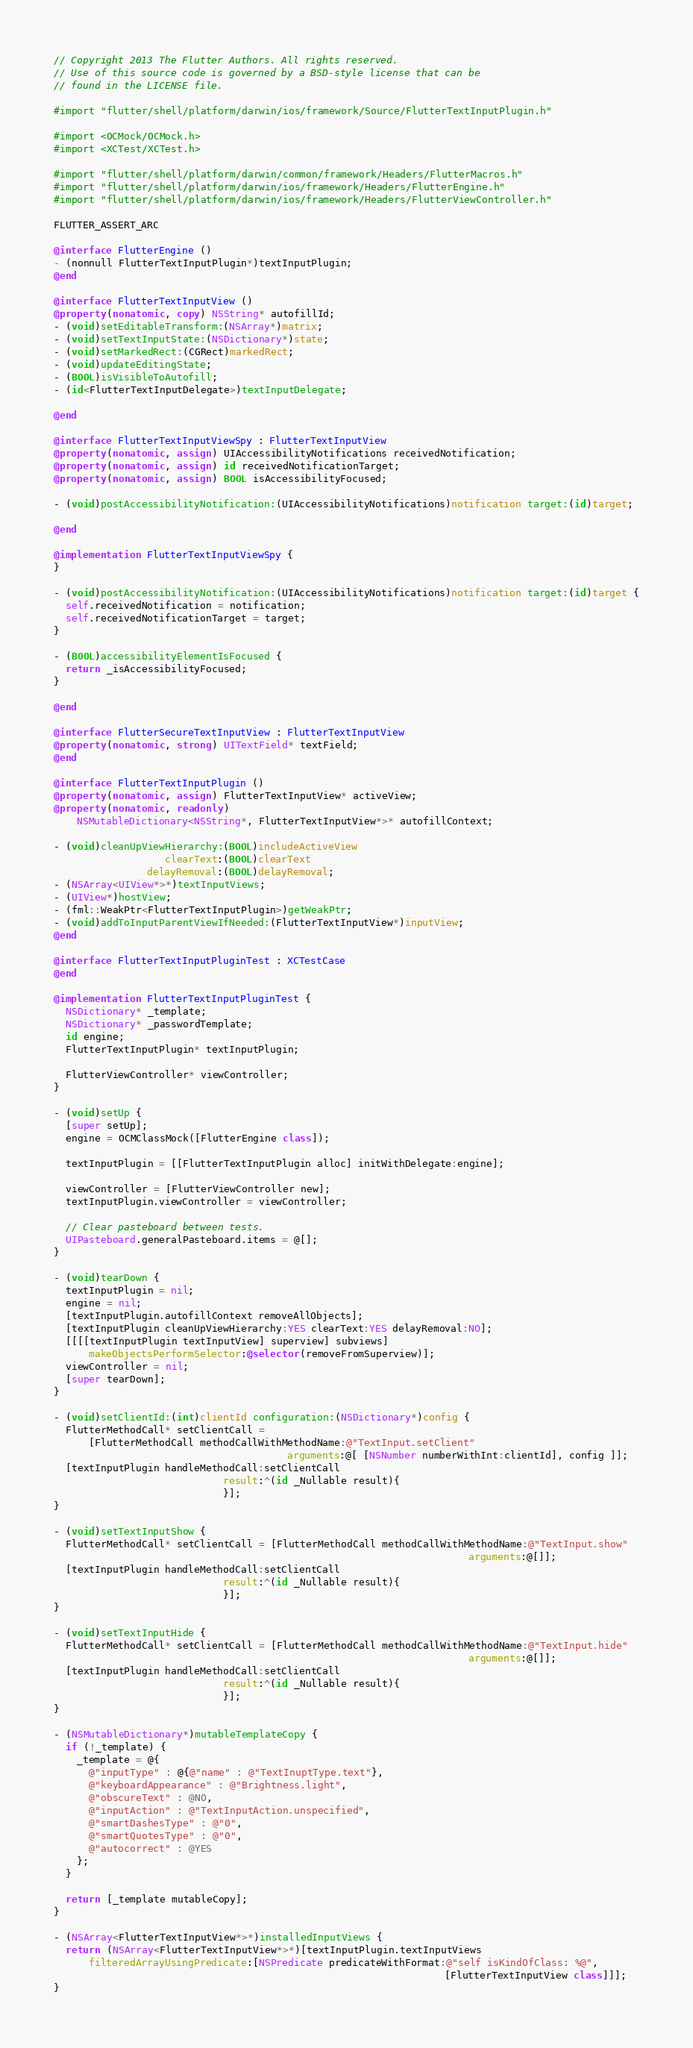<code> <loc_0><loc_0><loc_500><loc_500><_ObjectiveC_>// Copyright 2013 The Flutter Authors. All rights reserved.
// Use of this source code is governed by a BSD-style license that can be
// found in the LICENSE file.

#import "flutter/shell/platform/darwin/ios/framework/Source/FlutterTextInputPlugin.h"

#import <OCMock/OCMock.h>
#import <XCTest/XCTest.h>

#import "flutter/shell/platform/darwin/common/framework/Headers/FlutterMacros.h"
#import "flutter/shell/platform/darwin/ios/framework/Headers/FlutterEngine.h"
#import "flutter/shell/platform/darwin/ios/framework/Headers/FlutterViewController.h"

FLUTTER_ASSERT_ARC

@interface FlutterEngine ()
- (nonnull FlutterTextInputPlugin*)textInputPlugin;
@end

@interface FlutterTextInputView ()
@property(nonatomic, copy) NSString* autofillId;
- (void)setEditableTransform:(NSArray*)matrix;
- (void)setTextInputState:(NSDictionary*)state;
- (void)setMarkedRect:(CGRect)markedRect;
- (void)updateEditingState;
- (BOOL)isVisibleToAutofill;
- (id<FlutterTextInputDelegate>)textInputDelegate;

@end

@interface FlutterTextInputViewSpy : FlutterTextInputView
@property(nonatomic, assign) UIAccessibilityNotifications receivedNotification;
@property(nonatomic, assign) id receivedNotificationTarget;
@property(nonatomic, assign) BOOL isAccessibilityFocused;

- (void)postAccessibilityNotification:(UIAccessibilityNotifications)notification target:(id)target;

@end

@implementation FlutterTextInputViewSpy {
}

- (void)postAccessibilityNotification:(UIAccessibilityNotifications)notification target:(id)target {
  self.receivedNotification = notification;
  self.receivedNotificationTarget = target;
}

- (BOOL)accessibilityElementIsFocused {
  return _isAccessibilityFocused;
}

@end

@interface FlutterSecureTextInputView : FlutterTextInputView
@property(nonatomic, strong) UITextField* textField;
@end

@interface FlutterTextInputPlugin ()
@property(nonatomic, assign) FlutterTextInputView* activeView;
@property(nonatomic, readonly)
    NSMutableDictionary<NSString*, FlutterTextInputView*>* autofillContext;

- (void)cleanUpViewHierarchy:(BOOL)includeActiveView
                   clearText:(BOOL)clearText
                delayRemoval:(BOOL)delayRemoval;
- (NSArray<UIView*>*)textInputViews;
- (UIView*)hostView;
- (fml::WeakPtr<FlutterTextInputPlugin>)getWeakPtr;
- (void)addToInputParentViewIfNeeded:(FlutterTextInputView*)inputView;
@end

@interface FlutterTextInputPluginTest : XCTestCase
@end

@implementation FlutterTextInputPluginTest {
  NSDictionary* _template;
  NSDictionary* _passwordTemplate;
  id engine;
  FlutterTextInputPlugin* textInputPlugin;

  FlutterViewController* viewController;
}

- (void)setUp {
  [super setUp];
  engine = OCMClassMock([FlutterEngine class]);

  textInputPlugin = [[FlutterTextInputPlugin alloc] initWithDelegate:engine];

  viewController = [FlutterViewController new];
  textInputPlugin.viewController = viewController;

  // Clear pasteboard between tests.
  UIPasteboard.generalPasteboard.items = @[];
}

- (void)tearDown {
  textInputPlugin = nil;
  engine = nil;
  [textInputPlugin.autofillContext removeAllObjects];
  [textInputPlugin cleanUpViewHierarchy:YES clearText:YES delayRemoval:NO];
  [[[[textInputPlugin textInputView] superview] subviews]
      makeObjectsPerformSelector:@selector(removeFromSuperview)];
  viewController = nil;
  [super tearDown];
}

- (void)setClientId:(int)clientId configuration:(NSDictionary*)config {
  FlutterMethodCall* setClientCall =
      [FlutterMethodCall methodCallWithMethodName:@"TextInput.setClient"
                                        arguments:@[ [NSNumber numberWithInt:clientId], config ]];
  [textInputPlugin handleMethodCall:setClientCall
                             result:^(id _Nullable result){
                             }];
}

- (void)setTextInputShow {
  FlutterMethodCall* setClientCall = [FlutterMethodCall methodCallWithMethodName:@"TextInput.show"
                                                                       arguments:@[]];
  [textInputPlugin handleMethodCall:setClientCall
                             result:^(id _Nullable result){
                             }];
}

- (void)setTextInputHide {
  FlutterMethodCall* setClientCall = [FlutterMethodCall methodCallWithMethodName:@"TextInput.hide"
                                                                       arguments:@[]];
  [textInputPlugin handleMethodCall:setClientCall
                             result:^(id _Nullable result){
                             }];
}

- (NSMutableDictionary*)mutableTemplateCopy {
  if (!_template) {
    _template = @{
      @"inputType" : @{@"name" : @"TextInuptType.text"},
      @"keyboardAppearance" : @"Brightness.light",
      @"obscureText" : @NO,
      @"inputAction" : @"TextInputAction.unspecified",
      @"smartDashesType" : @"0",
      @"smartQuotesType" : @"0",
      @"autocorrect" : @YES
    };
  }

  return [_template mutableCopy];
}

- (NSArray<FlutterTextInputView*>*)installedInputViews {
  return (NSArray<FlutterTextInputView*>*)[textInputPlugin.textInputViews
      filteredArrayUsingPredicate:[NSPredicate predicateWithFormat:@"self isKindOfClass: %@",
                                                                   [FlutterTextInputView class]]];
}
</code> 